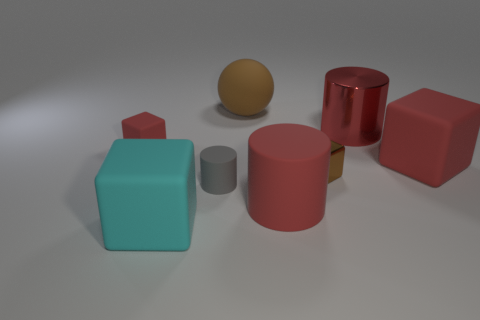Is there a small cylinder behind the brown object that is in front of the red rubber thing that is on the right side of the large metal cylinder?
Ensure brevity in your answer.  No. Is the red matte cylinder the same size as the cyan thing?
Give a very brief answer. Yes. There is a small rubber object on the right side of the large rubber cube in front of the red block to the right of the big cyan cube; what is its color?
Provide a short and direct response. Gray. What number of objects are the same color as the tiny metallic block?
Your answer should be compact. 1. How many large things are brown things or brown rubber spheres?
Your answer should be very brief. 1. Are there any brown rubber things that have the same shape as the big cyan rubber object?
Your answer should be compact. No. Do the small red matte thing and the red metal object have the same shape?
Provide a succinct answer. No. There is a matte block right of the brown thing in front of the big brown object; what color is it?
Your answer should be compact. Red. There is a rubber block that is the same size as the brown metal cube; what color is it?
Give a very brief answer. Red. What number of rubber objects are either tiny brown cylinders or large cyan blocks?
Offer a very short reply. 1. 